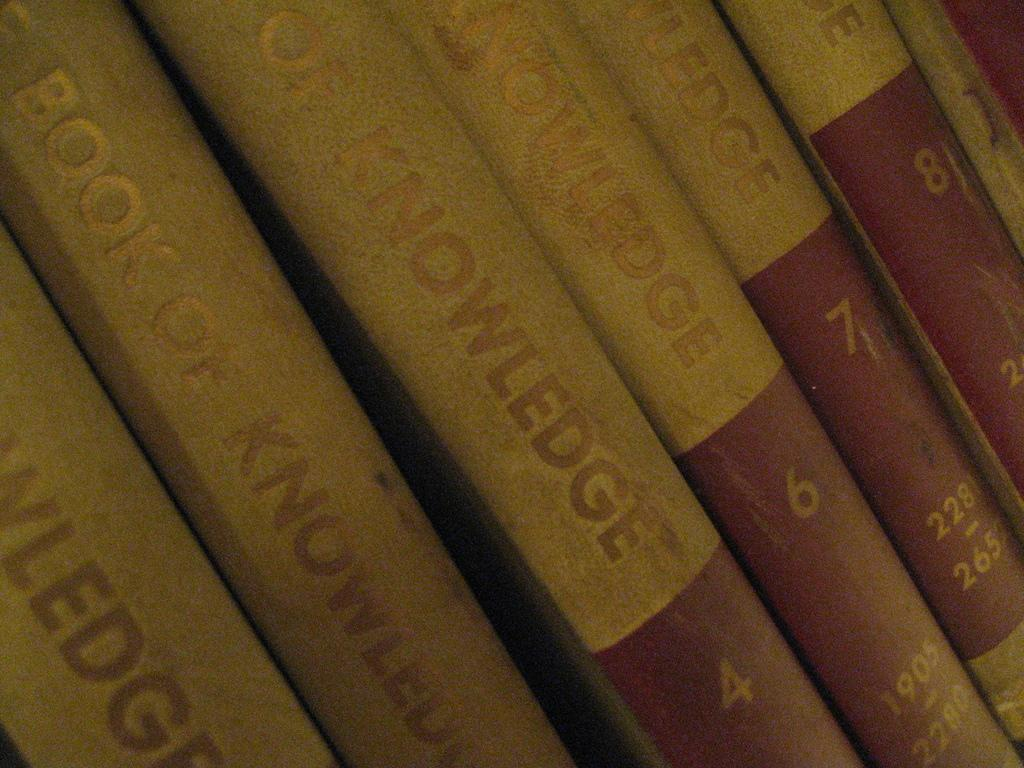Provide a one-sentence caption for the provided image. Several books of knowledge are lined up in a row. 